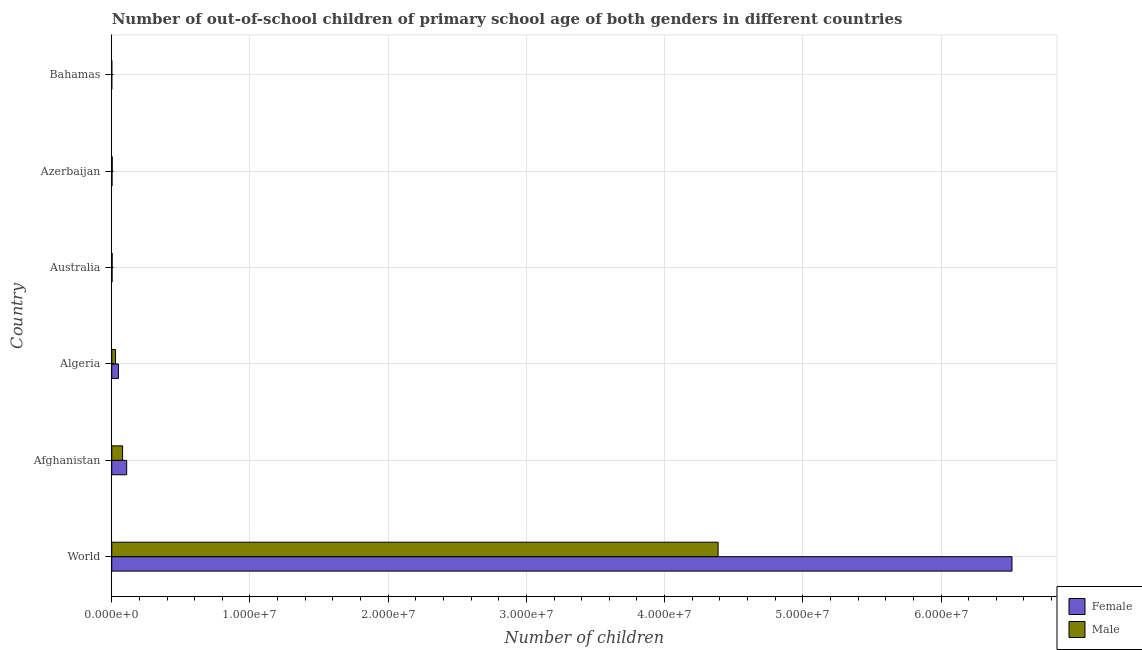How many different coloured bars are there?
Ensure brevity in your answer.  2. How many bars are there on the 6th tick from the bottom?
Ensure brevity in your answer.  2. What is the label of the 6th group of bars from the top?
Make the answer very short. World. What is the number of male out-of-school students in Afghanistan?
Offer a very short reply. 7.84e+05. Across all countries, what is the maximum number of male out-of-school students?
Your answer should be very brief. 4.39e+07. Across all countries, what is the minimum number of female out-of-school students?
Give a very brief answer. 1789. In which country was the number of male out-of-school students maximum?
Offer a very short reply. World. In which country was the number of male out-of-school students minimum?
Make the answer very short. Bahamas. What is the total number of male out-of-school students in the graph?
Ensure brevity in your answer.  4.50e+07. What is the difference between the number of female out-of-school students in Afghanistan and that in Azerbaijan?
Provide a short and direct response. 1.06e+06. What is the difference between the number of female out-of-school students in Azerbaijan and the number of male out-of-school students in Bahamas?
Provide a succinct answer. 1.96e+04. What is the average number of female out-of-school students per country?
Keep it short and to the point. 1.11e+07. What is the difference between the number of male out-of-school students and number of female out-of-school students in Afghanistan?
Your response must be concise. -2.95e+05. What is the ratio of the number of male out-of-school students in Afghanistan to that in Bahamas?
Your response must be concise. 362.12. What is the difference between the highest and the second highest number of male out-of-school students?
Your answer should be very brief. 4.31e+07. What is the difference between the highest and the lowest number of female out-of-school students?
Give a very brief answer. 6.51e+07. In how many countries, is the number of female out-of-school students greater than the average number of female out-of-school students taken over all countries?
Offer a terse response. 1. Is the sum of the number of female out-of-school students in Algeria and Azerbaijan greater than the maximum number of male out-of-school students across all countries?
Make the answer very short. No. What does the 1st bar from the top in Afghanistan represents?
Offer a terse response. Male. What is the difference between two consecutive major ticks on the X-axis?
Your answer should be very brief. 1.00e+07. Are the values on the major ticks of X-axis written in scientific E-notation?
Offer a very short reply. Yes. Does the graph contain any zero values?
Your answer should be very brief. No. What is the title of the graph?
Give a very brief answer. Number of out-of-school children of primary school age of both genders in different countries. What is the label or title of the X-axis?
Make the answer very short. Number of children. What is the Number of children in Female in World?
Provide a short and direct response. 6.51e+07. What is the Number of children in Male in World?
Make the answer very short. 4.39e+07. What is the Number of children of Female in Afghanistan?
Give a very brief answer. 1.08e+06. What is the Number of children in Male in Afghanistan?
Provide a succinct answer. 7.84e+05. What is the Number of children of Female in Algeria?
Offer a terse response. 4.83e+05. What is the Number of children of Male in Algeria?
Make the answer very short. 2.74e+05. What is the Number of children in Female in Australia?
Make the answer very short. 2.55e+04. What is the Number of children in Male in Australia?
Keep it short and to the point. 3.18e+04. What is the Number of children of Female in Azerbaijan?
Your response must be concise. 2.18e+04. What is the Number of children in Male in Azerbaijan?
Your response must be concise. 3.67e+04. What is the Number of children in Female in Bahamas?
Offer a terse response. 1789. What is the Number of children in Male in Bahamas?
Keep it short and to the point. 2166. Across all countries, what is the maximum Number of children in Female?
Provide a succinct answer. 6.51e+07. Across all countries, what is the maximum Number of children of Male?
Give a very brief answer. 4.39e+07. Across all countries, what is the minimum Number of children in Female?
Provide a succinct answer. 1789. Across all countries, what is the minimum Number of children in Male?
Provide a succinct answer. 2166. What is the total Number of children of Female in the graph?
Make the answer very short. 6.67e+07. What is the total Number of children of Male in the graph?
Your answer should be compact. 4.50e+07. What is the difference between the Number of children in Female in World and that in Afghanistan?
Ensure brevity in your answer.  6.41e+07. What is the difference between the Number of children of Male in World and that in Afghanistan?
Keep it short and to the point. 4.31e+07. What is the difference between the Number of children of Female in World and that in Algeria?
Provide a short and direct response. 6.46e+07. What is the difference between the Number of children of Male in World and that in Algeria?
Make the answer very short. 4.36e+07. What is the difference between the Number of children of Female in World and that in Australia?
Offer a very short reply. 6.51e+07. What is the difference between the Number of children of Male in World and that in Australia?
Provide a succinct answer. 4.38e+07. What is the difference between the Number of children in Female in World and that in Azerbaijan?
Your response must be concise. 6.51e+07. What is the difference between the Number of children of Male in World and that in Azerbaijan?
Give a very brief answer. 4.38e+07. What is the difference between the Number of children in Female in World and that in Bahamas?
Your answer should be compact. 6.51e+07. What is the difference between the Number of children in Male in World and that in Bahamas?
Offer a terse response. 4.39e+07. What is the difference between the Number of children in Female in Afghanistan and that in Algeria?
Your response must be concise. 5.97e+05. What is the difference between the Number of children in Male in Afghanistan and that in Algeria?
Make the answer very short. 5.10e+05. What is the difference between the Number of children in Female in Afghanistan and that in Australia?
Your answer should be very brief. 1.05e+06. What is the difference between the Number of children of Male in Afghanistan and that in Australia?
Provide a succinct answer. 7.53e+05. What is the difference between the Number of children in Female in Afghanistan and that in Azerbaijan?
Provide a short and direct response. 1.06e+06. What is the difference between the Number of children of Male in Afghanistan and that in Azerbaijan?
Give a very brief answer. 7.48e+05. What is the difference between the Number of children of Female in Afghanistan and that in Bahamas?
Your response must be concise. 1.08e+06. What is the difference between the Number of children in Male in Afghanistan and that in Bahamas?
Keep it short and to the point. 7.82e+05. What is the difference between the Number of children of Female in Algeria and that in Australia?
Your response must be concise. 4.57e+05. What is the difference between the Number of children in Male in Algeria and that in Australia?
Your response must be concise. 2.42e+05. What is the difference between the Number of children of Female in Algeria and that in Azerbaijan?
Provide a succinct answer. 4.61e+05. What is the difference between the Number of children in Male in Algeria and that in Azerbaijan?
Keep it short and to the point. 2.37e+05. What is the difference between the Number of children in Female in Algeria and that in Bahamas?
Make the answer very short. 4.81e+05. What is the difference between the Number of children of Male in Algeria and that in Bahamas?
Provide a short and direct response. 2.72e+05. What is the difference between the Number of children in Female in Australia and that in Azerbaijan?
Your answer should be very brief. 3732. What is the difference between the Number of children in Male in Australia and that in Azerbaijan?
Offer a terse response. -4934. What is the difference between the Number of children in Female in Australia and that in Bahamas?
Ensure brevity in your answer.  2.37e+04. What is the difference between the Number of children of Male in Australia and that in Bahamas?
Make the answer very short. 2.96e+04. What is the difference between the Number of children in Female in Azerbaijan and that in Bahamas?
Provide a succinct answer. 2.00e+04. What is the difference between the Number of children in Male in Azerbaijan and that in Bahamas?
Ensure brevity in your answer.  3.46e+04. What is the difference between the Number of children of Female in World and the Number of children of Male in Afghanistan?
Offer a terse response. 6.43e+07. What is the difference between the Number of children of Female in World and the Number of children of Male in Algeria?
Make the answer very short. 6.49e+07. What is the difference between the Number of children of Female in World and the Number of children of Male in Australia?
Keep it short and to the point. 6.51e+07. What is the difference between the Number of children of Female in World and the Number of children of Male in Azerbaijan?
Offer a terse response. 6.51e+07. What is the difference between the Number of children in Female in World and the Number of children in Male in Bahamas?
Your response must be concise. 6.51e+07. What is the difference between the Number of children of Female in Afghanistan and the Number of children of Male in Algeria?
Make the answer very short. 8.05e+05. What is the difference between the Number of children of Female in Afghanistan and the Number of children of Male in Australia?
Give a very brief answer. 1.05e+06. What is the difference between the Number of children of Female in Afghanistan and the Number of children of Male in Azerbaijan?
Your response must be concise. 1.04e+06. What is the difference between the Number of children in Female in Afghanistan and the Number of children in Male in Bahamas?
Give a very brief answer. 1.08e+06. What is the difference between the Number of children of Female in Algeria and the Number of children of Male in Australia?
Give a very brief answer. 4.51e+05. What is the difference between the Number of children in Female in Algeria and the Number of children in Male in Azerbaijan?
Offer a very short reply. 4.46e+05. What is the difference between the Number of children of Female in Algeria and the Number of children of Male in Bahamas?
Your answer should be compact. 4.81e+05. What is the difference between the Number of children in Female in Australia and the Number of children in Male in Azerbaijan?
Ensure brevity in your answer.  -1.12e+04. What is the difference between the Number of children of Female in Australia and the Number of children of Male in Bahamas?
Give a very brief answer. 2.34e+04. What is the difference between the Number of children of Female in Azerbaijan and the Number of children of Male in Bahamas?
Your answer should be compact. 1.96e+04. What is the average Number of children of Female per country?
Make the answer very short. 1.11e+07. What is the average Number of children in Male per country?
Provide a succinct answer. 7.50e+06. What is the difference between the Number of children of Female and Number of children of Male in World?
Offer a very short reply. 2.13e+07. What is the difference between the Number of children of Female and Number of children of Male in Afghanistan?
Provide a succinct answer. 2.95e+05. What is the difference between the Number of children in Female and Number of children in Male in Algeria?
Your response must be concise. 2.09e+05. What is the difference between the Number of children in Female and Number of children in Male in Australia?
Offer a terse response. -6289. What is the difference between the Number of children in Female and Number of children in Male in Azerbaijan?
Your answer should be compact. -1.50e+04. What is the difference between the Number of children of Female and Number of children of Male in Bahamas?
Your answer should be very brief. -377. What is the ratio of the Number of children in Female in World to that in Afghanistan?
Keep it short and to the point. 60.34. What is the ratio of the Number of children in Male in World to that in Afghanistan?
Keep it short and to the point. 55.93. What is the ratio of the Number of children of Female in World to that in Algeria?
Offer a very short reply. 134.92. What is the ratio of the Number of children in Male in World to that in Algeria?
Provide a short and direct response. 160.07. What is the ratio of the Number of children of Female in World to that in Australia?
Ensure brevity in your answer.  2552.55. What is the ratio of the Number of children in Male in World to that in Australia?
Offer a terse response. 1379.33. What is the ratio of the Number of children of Female in World to that in Azerbaijan?
Provide a short and direct response. 2989.85. What is the ratio of the Number of children in Male in World to that in Azerbaijan?
Give a very brief answer. 1194.09. What is the ratio of the Number of children of Female in World to that in Bahamas?
Make the answer very short. 3.64e+04. What is the ratio of the Number of children of Male in World to that in Bahamas?
Your answer should be very brief. 2.03e+04. What is the ratio of the Number of children in Female in Afghanistan to that in Algeria?
Ensure brevity in your answer.  2.24. What is the ratio of the Number of children of Male in Afghanistan to that in Algeria?
Offer a very short reply. 2.86. What is the ratio of the Number of children in Female in Afghanistan to that in Australia?
Keep it short and to the point. 42.3. What is the ratio of the Number of children in Male in Afghanistan to that in Australia?
Your answer should be very brief. 24.66. What is the ratio of the Number of children in Female in Afghanistan to that in Azerbaijan?
Your response must be concise. 49.55. What is the ratio of the Number of children in Male in Afghanistan to that in Azerbaijan?
Make the answer very short. 21.35. What is the ratio of the Number of children in Female in Afghanistan to that in Bahamas?
Offer a very short reply. 603.33. What is the ratio of the Number of children in Male in Afghanistan to that in Bahamas?
Your answer should be compact. 362.12. What is the ratio of the Number of children of Female in Algeria to that in Australia?
Keep it short and to the point. 18.92. What is the ratio of the Number of children in Male in Algeria to that in Australia?
Provide a short and direct response. 8.62. What is the ratio of the Number of children in Female in Algeria to that in Azerbaijan?
Provide a short and direct response. 22.16. What is the ratio of the Number of children in Male in Algeria to that in Azerbaijan?
Your response must be concise. 7.46. What is the ratio of the Number of children in Female in Algeria to that in Bahamas?
Ensure brevity in your answer.  269.84. What is the ratio of the Number of children in Male in Algeria to that in Bahamas?
Offer a terse response. 126.53. What is the ratio of the Number of children of Female in Australia to that in Azerbaijan?
Your answer should be compact. 1.17. What is the ratio of the Number of children of Male in Australia to that in Azerbaijan?
Your response must be concise. 0.87. What is the ratio of the Number of children of Female in Australia to that in Bahamas?
Provide a short and direct response. 14.26. What is the ratio of the Number of children of Male in Australia to that in Bahamas?
Offer a terse response. 14.68. What is the ratio of the Number of children of Female in Azerbaijan to that in Bahamas?
Ensure brevity in your answer.  12.18. What is the ratio of the Number of children in Male in Azerbaijan to that in Bahamas?
Provide a short and direct response. 16.96. What is the difference between the highest and the second highest Number of children of Female?
Keep it short and to the point. 6.41e+07. What is the difference between the highest and the second highest Number of children of Male?
Provide a short and direct response. 4.31e+07. What is the difference between the highest and the lowest Number of children of Female?
Your answer should be very brief. 6.51e+07. What is the difference between the highest and the lowest Number of children in Male?
Keep it short and to the point. 4.39e+07. 